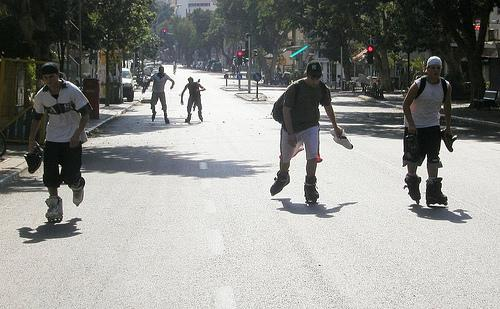What enables these people to go faster on the street?

Choices:
A) roller blades
B) ice skates
C) skate boards
D) roller skates roller blades 